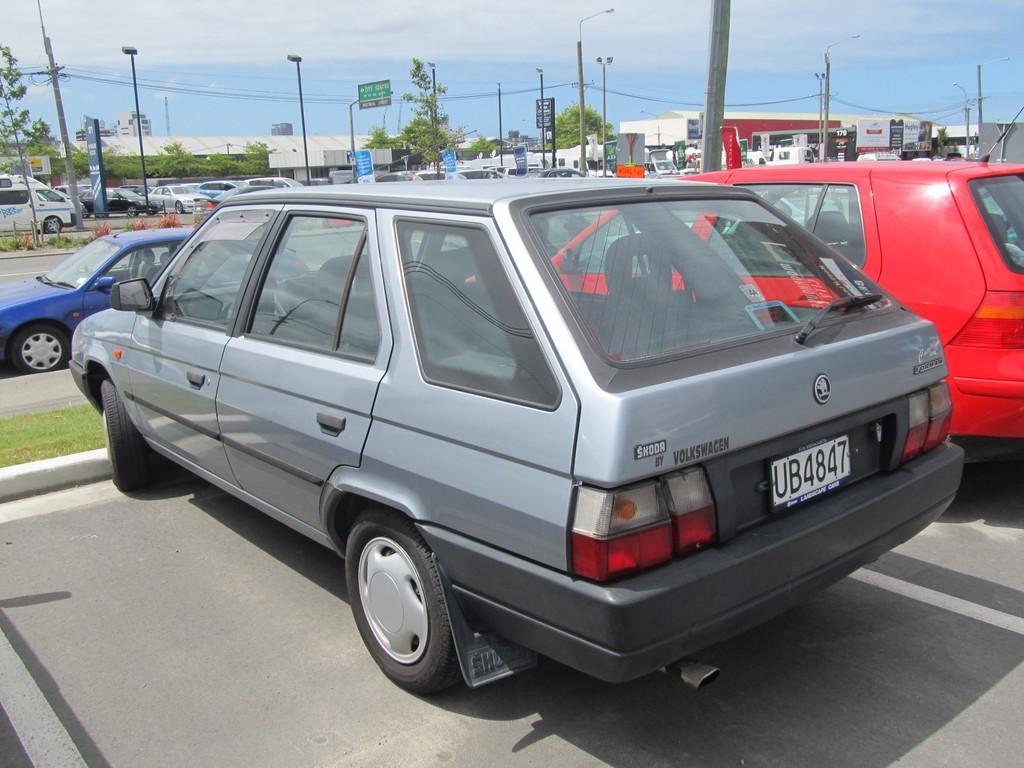Describe this image in one or two sentences. In this image in front there are cars parked on the road. We can see buildings, trees, street lights, sign boards and grass on the surface. In the background there is sky. 